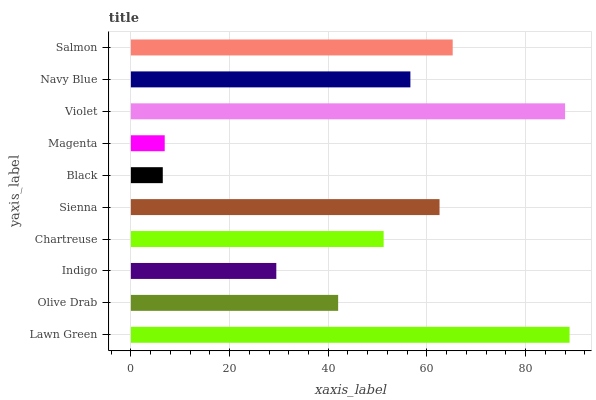Is Black the minimum?
Answer yes or no. Yes. Is Lawn Green the maximum?
Answer yes or no. Yes. Is Olive Drab the minimum?
Answer yes or no. No. Is Olive Drab the maximum?
Answer yes or no. No. Is Lawn Green greater than Olive Drab?
Answer yes or no. Yes. Is Olive Drab less than Lawn Green?
Answer yes or no. Yes. Is Olive Drab greater than Lawn Green?
Answer yes or no. No. Is Lawn Green less than Olive Drab?
Answer yes or no. No. Is Navy Blue the high median?
Answer yes or no. Yes. Is Chartreuse the low median?
Answer yes or no. Yes. Is Olive Drab the high median?
Answer yes or no. No. Is Olive Drab the low median?
Answer yes or no. No. 